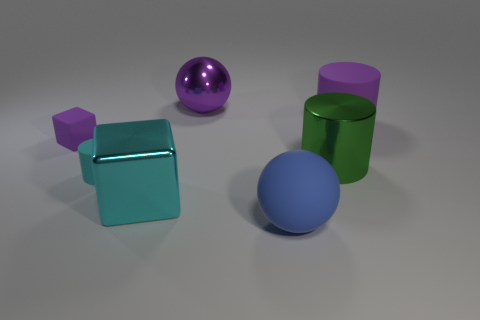Add 3 small gray shiny things. How many objects exist? 10 Subtract all cylinders. How many objects are left? 4 Subtract 1 green cylinders. How many objects are left? 6 Subtract all small gray matte blocks. Subtract all cyan metal objects. How many objects are left? 6 Add 7 cyan metal cubes. How many cyan metal cubes are left? 8 Add 4 purple things. How many purple things exist? 7 